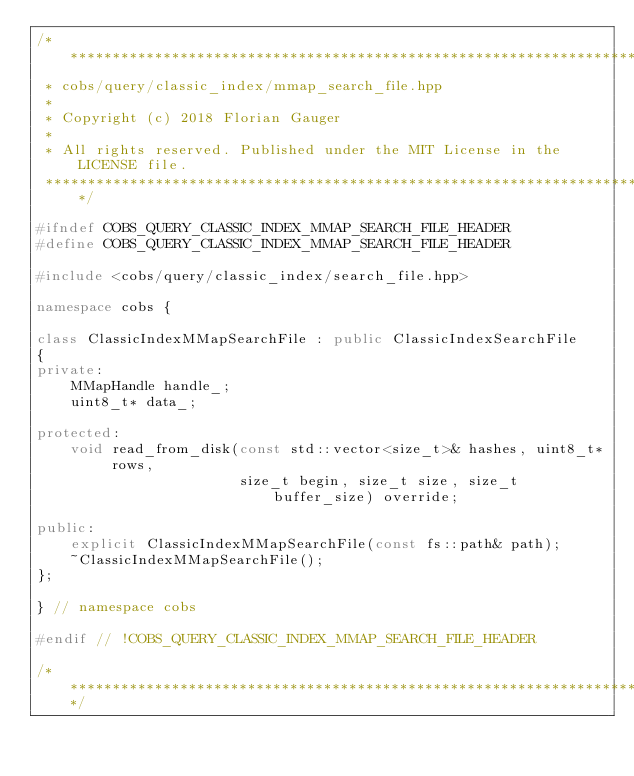<code> <loc_0><loc_0><loc_500><loc_500><_C++_>/*******************************************************************************
 * cobs/query/classic_index/mmap_search_file.hpp
 *
 * Copyright (c) 2018 Florian Gauger
 *
 * All rights reserved. Published under the MIT License in the LICENSE file.
 ******************************************************************************/

#ifndef COBS_QUERY_CLASSIC_INDEX_MMAP_SEARCH_FILE_HEADER
#define COBS_QUERY_CLASSIC_INDEX_MMAP_SEARCH_FILE_HEADER

#include <cobs/query/classic_index/search_file.hpp>

namespace cobs {

class ClassicIndexMMapSearchFile : public ClassicIndexSearchFile
{
private:
    MMapHandle handle_;
    uint8_t* data_;

protected:
    void read_from_disk(const std::vector<size_t>& hashes, uint8_t* rows,
                        size_t begin, size_t size, size_t buffer_size) override;

public:
    explicit ClassicIndexMMapSearchFile(const fs::path& path);
    ~ClassicIndexMMapSearchFile();
};

} // namespace cobs

#endif // !COBS_QUERY_CLASSIC_INDEX_MMAP_SEARCH_FILE_HEADER

/******************************************************************************/
</code> 